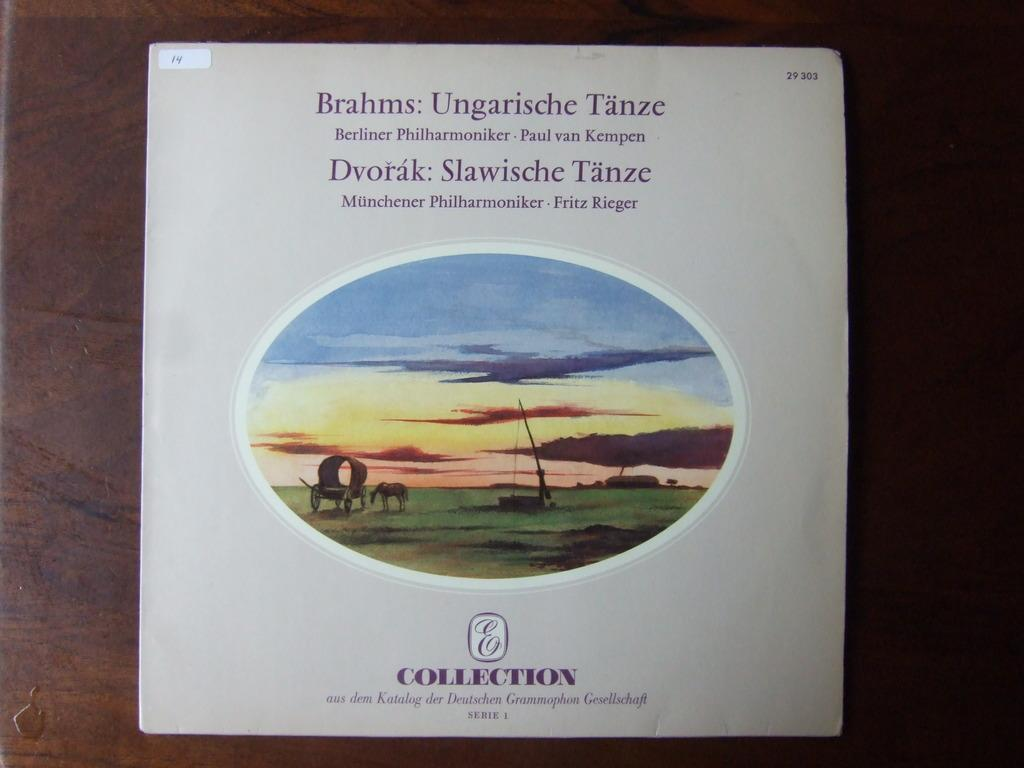<image>
Summarize the visual content of the image. A record album of classical music is part of the E Collection. 